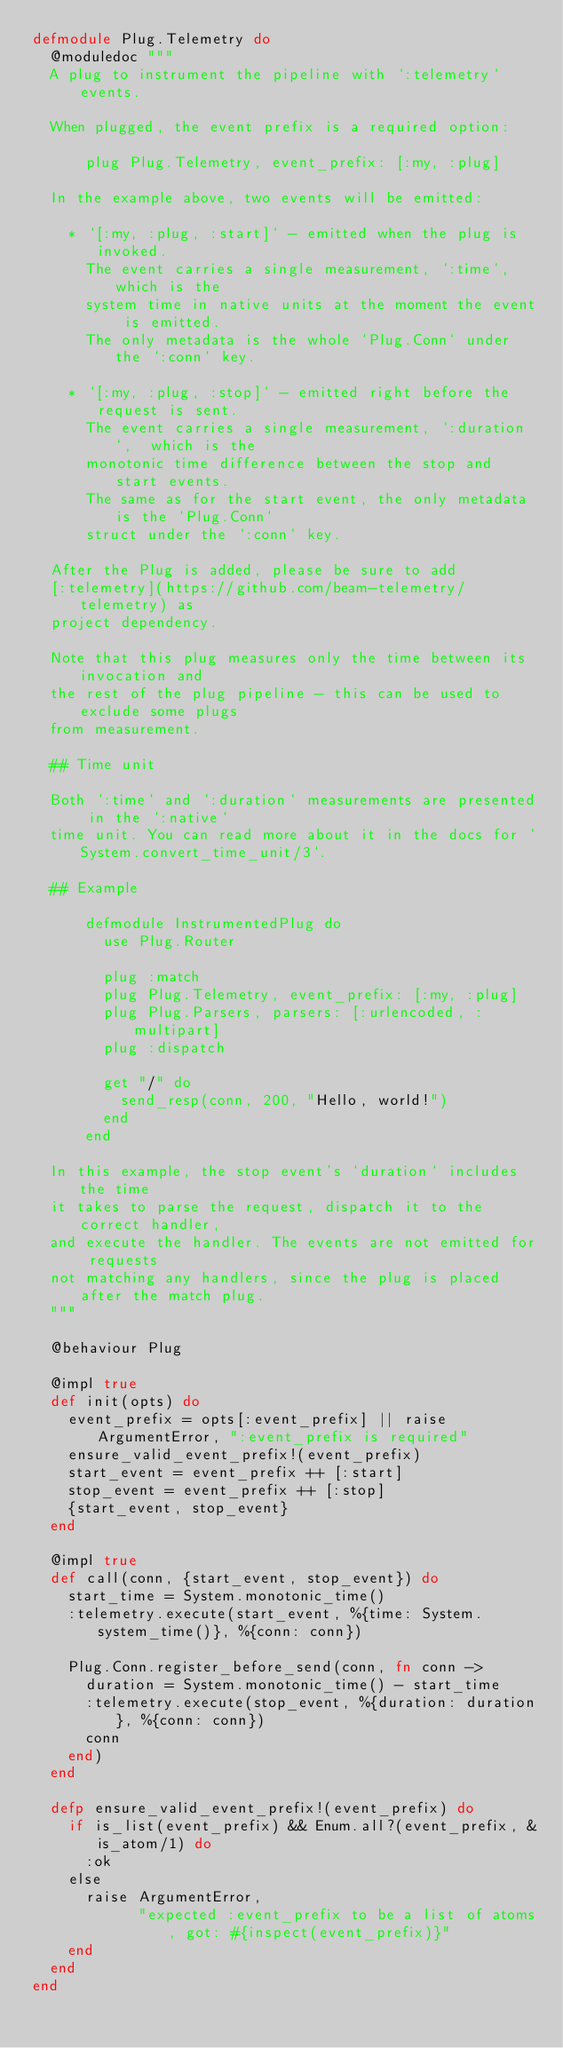Convert code to text. <code><loc_0><loc_0><loc_500><loc_500><_Elixir_>defmodule Plug.Telemetry do
  @moduledoc """
  A plug to instrument the pipeline with `:telemetry` events.

  When plugged, the event prefix is a required option:

      plug Plug.Telemetry, event_prefix: [:my, :plug]

  In the example above, two events will be emitted:

    * `[:my, :plug, :start]` - emitted when the plug is invoked.
      The event carries a single measurement, `:time`, which is the
      system time in native units at the moment the event is emitted.
      The only metadata is the whole `Plug.Conn` under the `:conn` key.

    * `[:my, :plug, :stop]` - emitted right before the request is sent.
      The event carries a single measurement, `:duration`,  which is the
      monotonic time difference between the stop and start events.
      The same as for the start event, the only metadata is the `Plug.Conn`
      struct under the `:conn` key.

  After the Plug is added, please be sure to add
  [:telemetry](https://github.com/beam-telemetry/telemetry) as
  project dependency.

  Note that this plug measures only the time between its invocation and
  the rest of the plug pipeline - this can be used to exclude some plugs
  from measurement.

  ## Time unit

  Both `:time` and `:duration` measurements are presented in the `:native`
  time unit. You can read more about it in the docs for `System.convert_time_unit/3`.

  ## Example

      defmodule InstrumentedPlug do
        use Plug.Router

        plug :match
        plug Plug.Telemetry, event_prefix: [:my, :plug]
        plug Plug.Parsers, parsers: [:urlencoded, :multipart]
        plug :dispatch

        get "/" do
          send_resp(conn, 200, "Hello, world!")
        end
      end

  In this example, the stop event's `duration` includes the time
  it takes to parse the request, dispatch it to the correct handler,
  and execute the handler. The events are not emitted for requests
  not matching any handlers, since the plug is placed after the match plug.
  """

  @behaviour Plug

  @impl true
  def init(opts) do
    event_prefix = opts[:event_prefix] || raise ArgumentError, ":event_prefix is required"
    ensure_valid_event_prefix!(event_prefix)
    start_event = event_prefix ++ [:start]
    stop_event = event_prefix ++ [:stop]
    {start_event, stop_event}
  end

  @impl true
  def call(conn, {start_event, stop_event}) do
    start_time = System.monotonic_time()
    :telemetry.execute(start_event, %{time: System.system_time()}, %{conn: conn})

    Plug.Conn.register_before_send(conn, fn conn ->
      duration = System.monotonic_time() - start_time
      :telemetry.execute(stop_event, %{duration: duration}, %{conn: conn})
      conn
    end)
  end

  defp ensure_valid_event_prefix!(event_prefix) do
    if is_list(event_prefix) && Enum.all?(event_prefix, &is_atom/1) do
      :ok
    else
      raise ArgumentError,
            "expected :event_prefix to be a list of atoms, got: #{inspect(event_prefix)}"
    end
  end
end
</code> 